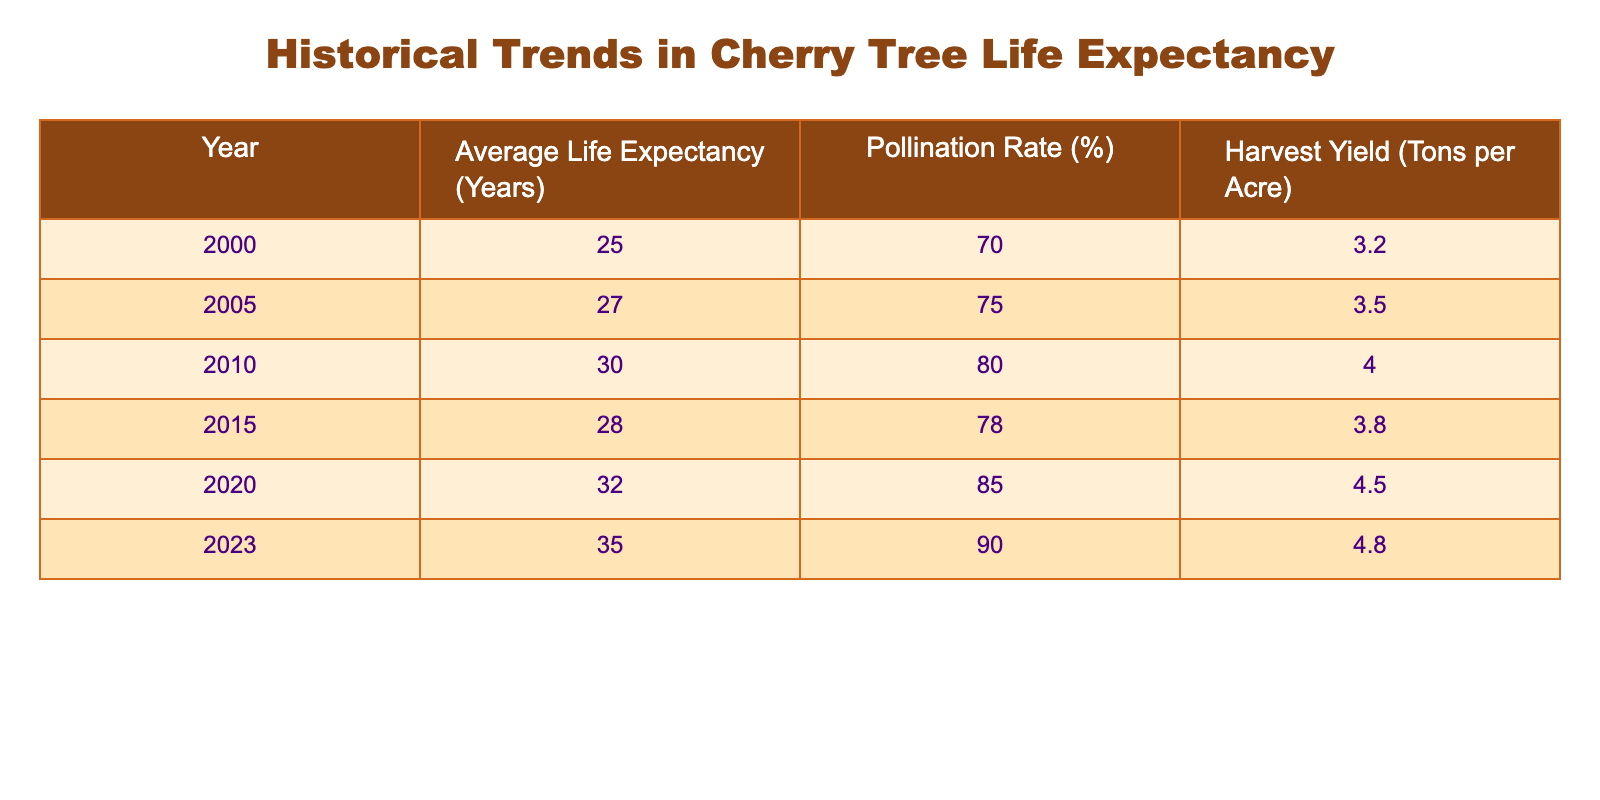What was the average life expectancy of cherry trees in 2010? By referring to the table, we can see that in 2010, the Average Life Expectancy of cherry trees is explicitly listed as 30 years.
Answer: 30 In which year did the harvest yield reach its peak? Looking at the Harvest Yield column, it can be observed that the highest value recorded is 4.8 tons per acre in the year 2023.
Answer: 2023 What is the percentage increase in pollination rate from 2000 to 2023? The pollination rate in 2000 was 70% and in 2023 it is 90%. The increase can be calculated as (90 - 70) = 20%.
Answer: 20% Is the average life expectancy of cherry trees consistently increasing over the years? By inspecting the Average Life Expectancy column, we see the values are: 25, 27, 30, 28, 32, and 35. The values show an increase from 2000 to 2010, a decrease in 2015, and then an increase again by 2023; therefore, it is not consistently increasing.
Answer: No What is the average harvest yield from the years 2000 to 2020? To find the average, we sum the harvest yields for the years listed: 3.2 + 3.5 + 4.0 + 3.8 + 4.5 = 18.0 tons. Dividing this sum by the number of years (5), we get an average of 18.0 / 5 = 3.6 tons per acre.
Answer: 3.6 Which year had the lowest pollination rate, and what was it? By examining the Pollination Rate column, the lowest value is 70%, which corresponds to the year 2000.
Answer: 2000, 70% If the trend continues as outlined in the table, what would be the expected average life expectancy in 2025 if the pattern holds? From the data, the life expectancy has been increasing over the years. The increase from 2020 to 2023 is 3 years over 3 years. If we continue the same increase, we might expect an increase of about 3 years, giving an estimated life expectancy of 35 + 3 = 38 years for 2025.
Answer: 38 Has there ever been a year where the harvest yield exceeded 4 tons per acre? In the Harvest Yield column, the values exceeding 4 tons per acre are 4.0 (2010), 4.5 (2020), and 4.8 (2023). Therefore, yes, there have been multiple instances.
Answer: Yes 